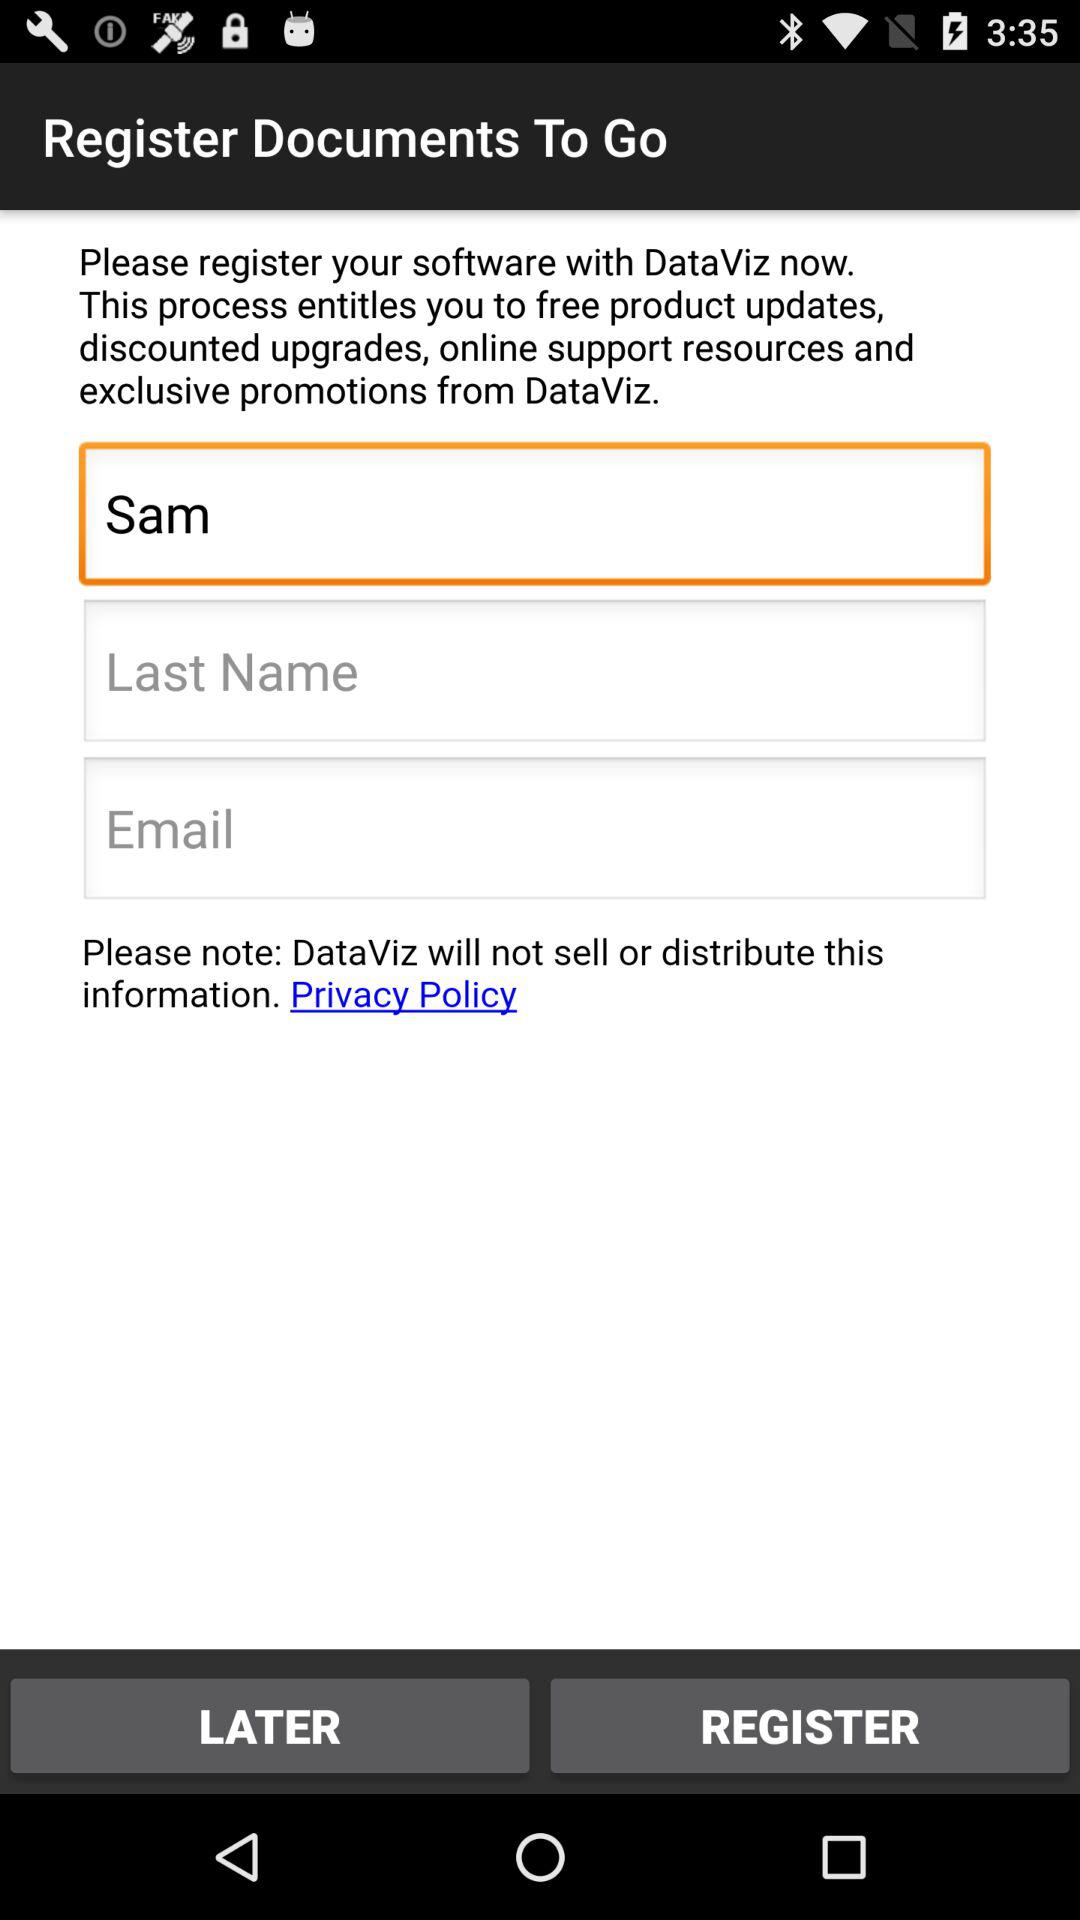What is the given first name? The given first name is Sam. 